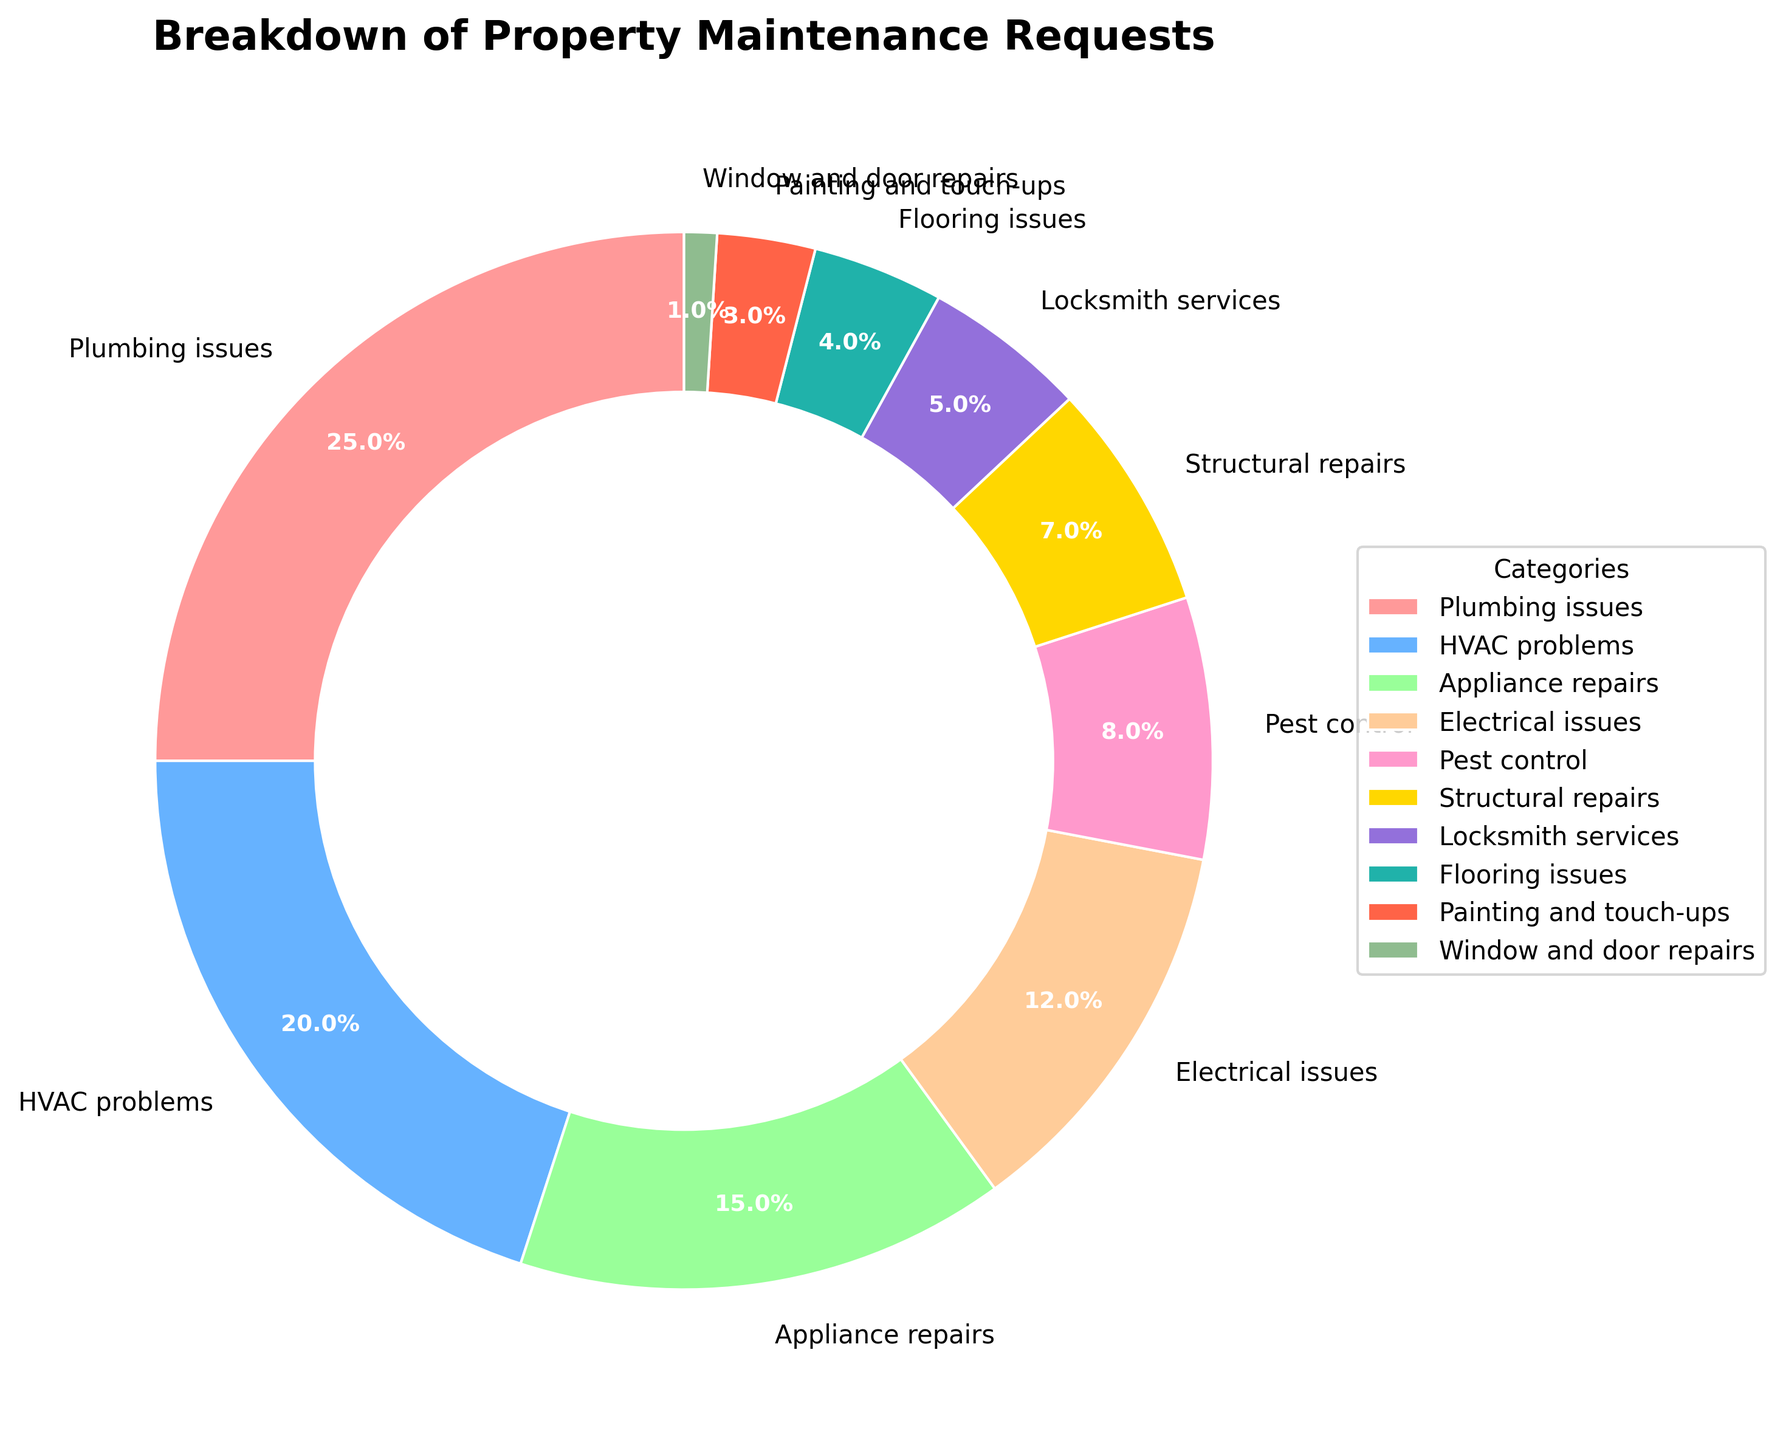What percentage of maintenance requests are related to HVAC problems and appliance repairs combined? The percentages for HVAC problems and appliance repairs are 20% and 15% respectively. Adding these together, 20% + 15% gives 35%.
Answer: 35% Which category has a higher percentage of maintenance requests: electrical issues or structural repairs? The percentage for electrical issues is 12% and for structural repairs is 7%. Comparing these values, 12% is greater than 7%.
Answer: Electrical issues How many categories account for less than 5% of maintenance requests each? To find categories accounting for less than 5%, look at the list: Locksmith services (5%), Flooring issues (4%), Painting and touch-ups (3%), and Window and door repairs (1%). Although locksmith services is exactly 5%, the other three categories are less than 5%.
Answer: 3 Which category has the least number of maintenance requests? By observing the percentages, Window and door repairs have the smallest share at 1%.
Answer: Window and door repairs Do plumbing issues make up more maintenance requests than pest control and painting and touch-ups combined? The percentage for plumbing issues is 25%. Pest control and painting and touch-ups are 8% and 3%, respectively. Adding pest control and painting and touch-ups together, 8% + 3% gives 11%. Since 25% is greater than 11%, plumbing issues indeed make up more.
Answer: Yes What is the total percentage of maintenance requests related to plumbing issues, HVAC problems, and electrical issues? Summing the percentages for plumbing issues (25%), HVAC problems (20%), and electrical issues (12%) gives: 25% + 20% + 12% = 57%.
Answer: 57% Which color represents pest control requests on the pie chart? The color used for the pest control slice in the pie chart is noted from the data: third from the bottom in the palette list applied, which is '#FFD700' (yellow).
Answer: Yellow Are there more requests for appliance repairs or for structural repairs and flooring issues combined? The percentage for appliance repairs is 15%. Structural repairs and flooring issues together make up 7% + 4%, which results in 11%. Since 15% is greater than 11%, appliance repairs have more requests.
Answer: Yes Is the percentage of HVAC problems closer to the percentage of appliance repairs or electrical issues? The percentage of HVAC problems is 20%. Appliance repairs are 15%, and electrical issues are 12%. The difference with appliance repairs is 5% (20% - 15%), and with electrical issues it is 8% (20% - 12%). Therefore, HVAC problems are closer to appliance repairs.
Answer: Appliance repairs What percentage of maintenance requests are related to plumbing issues, HVAC problems, and pest control combined? Adding the percentages for plumbing issues (25%), HVAC problems (20%), and pest control (8%) gives: 25% + 20% + 8% = 53%.
Answer: 53% 